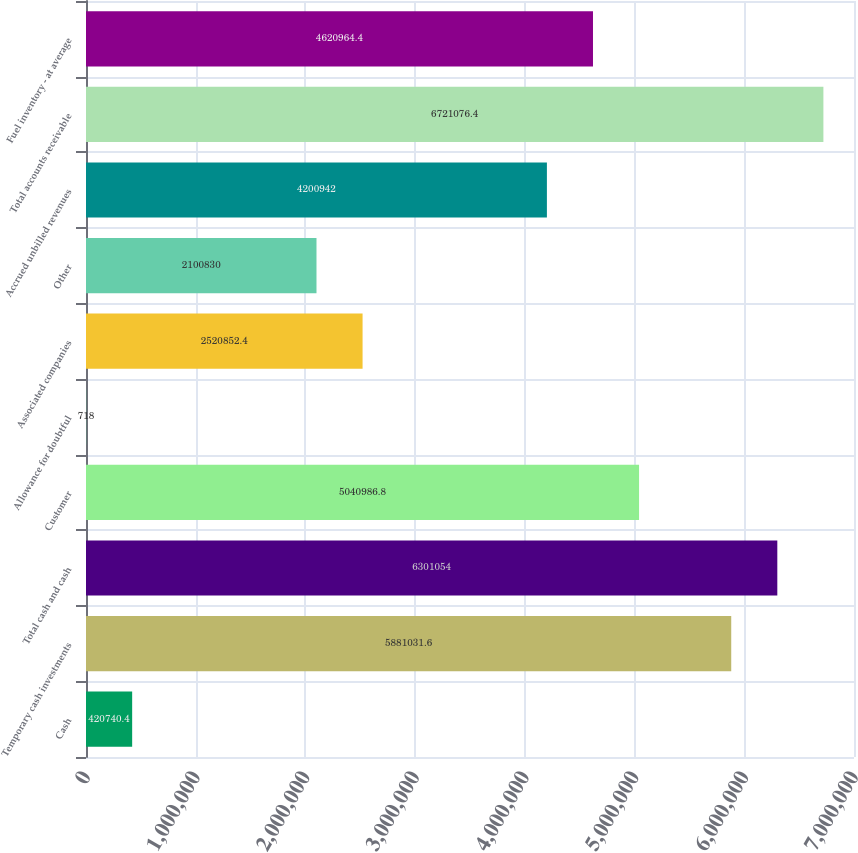Convert chart. <chart><loc_0><loc_0><loc_500><loc_500><bar_chart><fcel>Cash<fcel>Temporary cash investments<fcel>Total cash and cash<fcel>Customer<fcel>Allowance for doubtful<fcel>Associated companies<fcel>Other<fcel>Accrued unbilled revenues<fcel>Total accounts receivable<fcel>Fuel inventory - at average<nl><fcel>420740<fcel>5.88103e+06<fcel>6.30105e+06<fcel>5.04099e+06<fcel>718<fcel>2.52085e+06<fcel>2.10083e+06<fcel>4.20094e+06<fcel>6.72108e+06<fcel>4.62096e+06<nl></chart> 